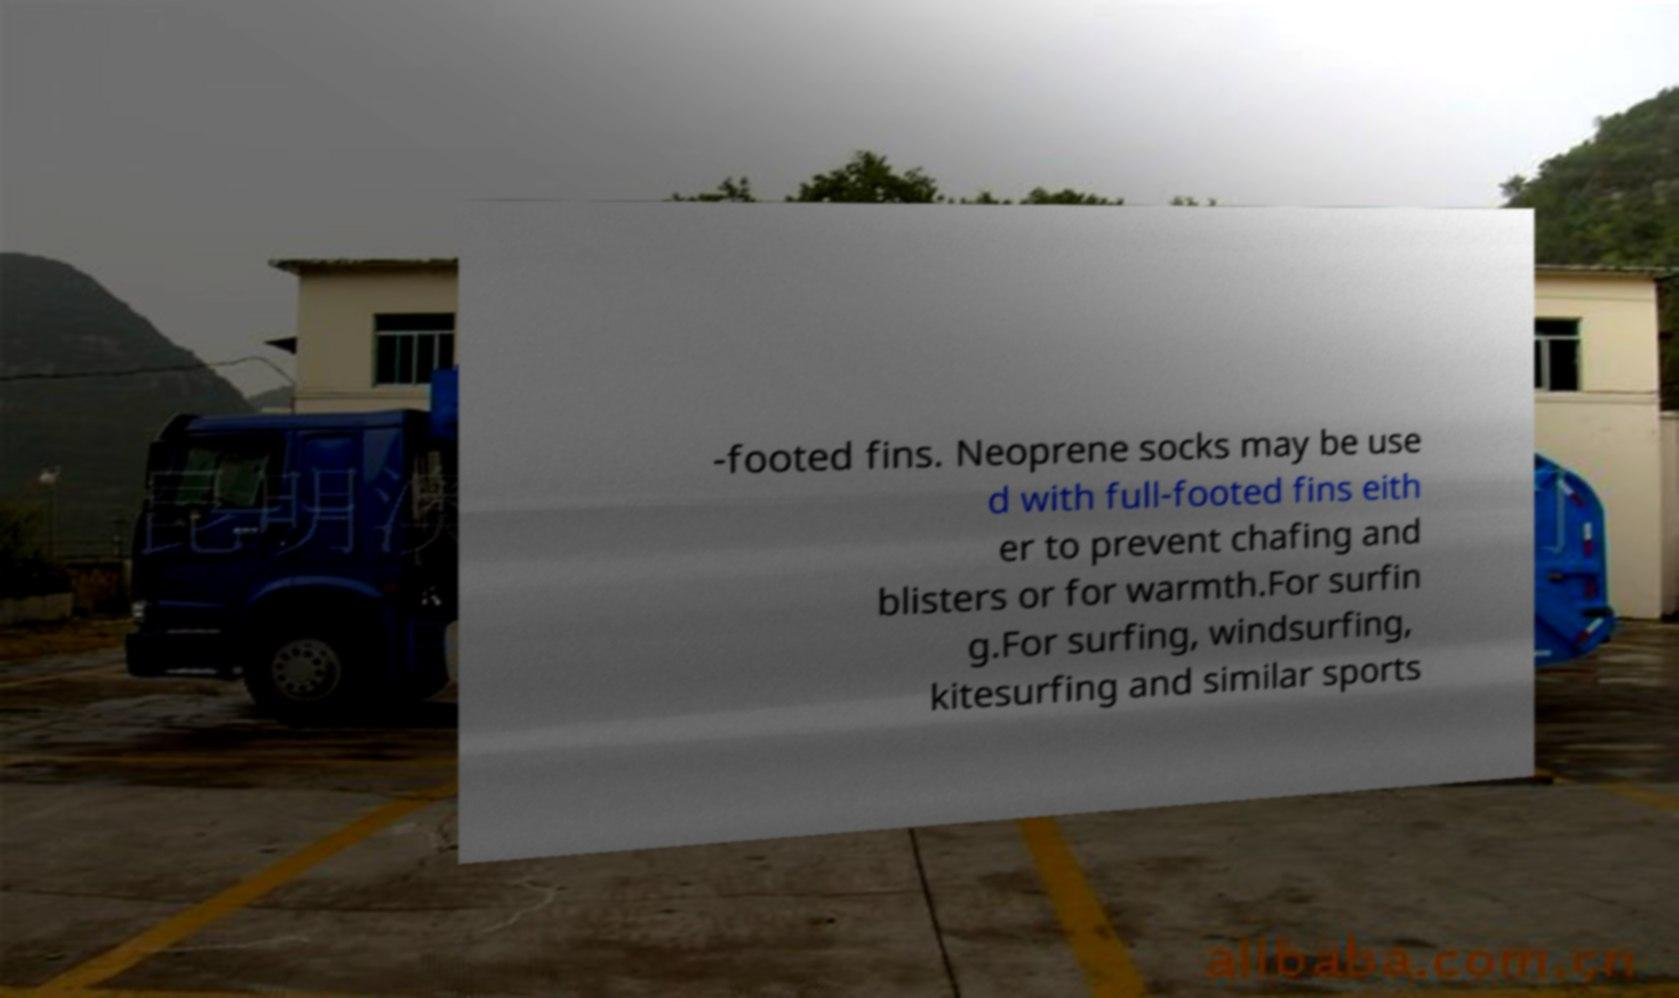There's text embedded in this image that I need extracted. Can you transcribe it verbatim? -footed fins. Neoprene socks may be use d with full-footed fins eith er to prevent chafing and blisters or for warmth.For surfin g.For surfing, windsurfing, kitesurfing and similar sports 